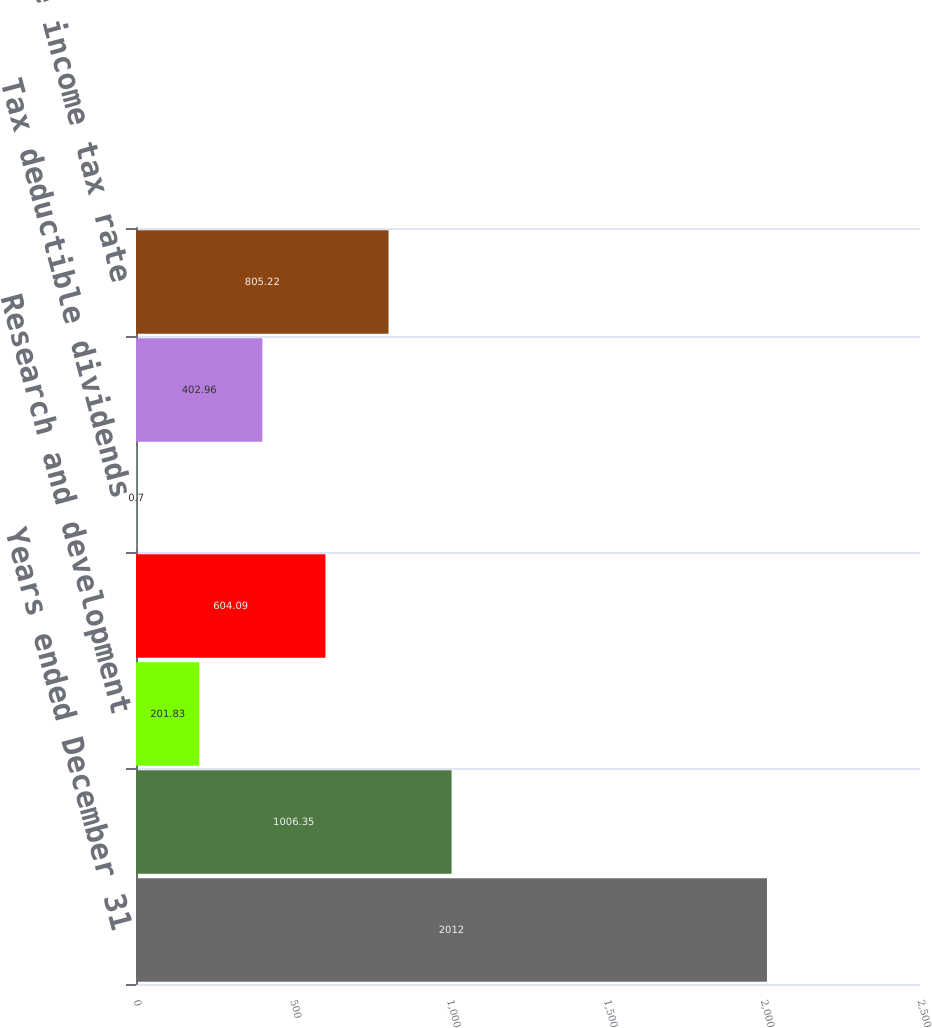<chart> <loc_0><loc_0><loc_500><loc_500><bar_chart><fcel>Years ended December 31<fcel>US federal statutory tax<fcel>Research and development<fcel>Tax on international<fcel>Tax deductible dividends<fcel>State income tax provision net<fcel>Effective income tax rate<nl><fcel>2012<fcel>1006.35<fcel>201.83<fcel>604.09<fcel>0.7<fcel>402.96<fcel>805.22<nl></chart> 